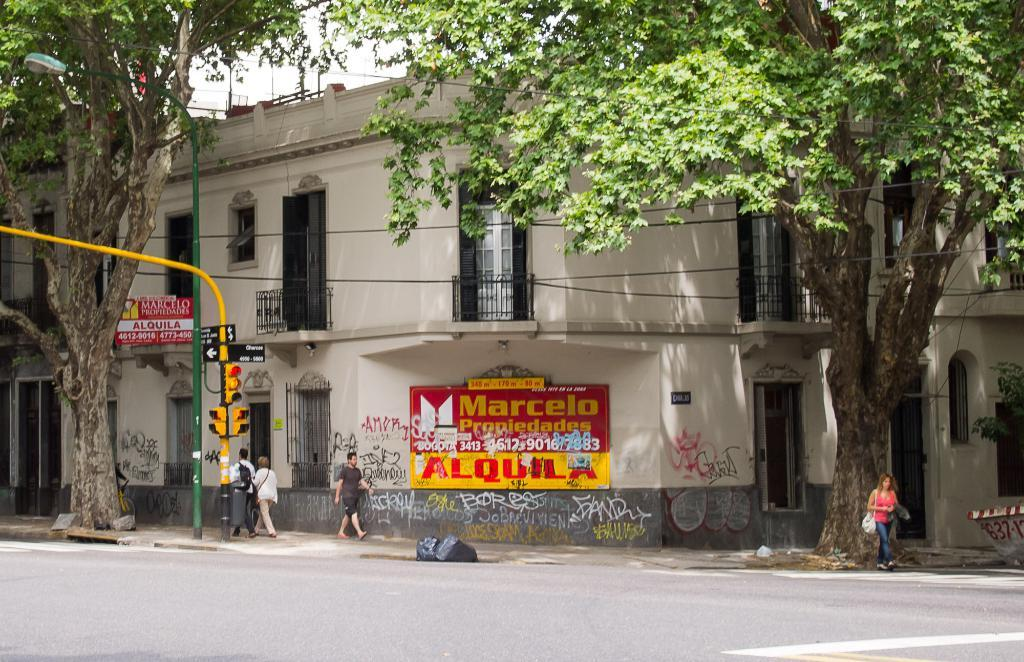How many people are in the group visible in the image? The number of people in the group cannot be determined from the provided facts. What type of vegetation is present in the image? There are trees in the image. What type of infrastructure can be seen in the image? Traffic lights and poles are visible in the image. What is on the building in the image? There are hoardings on a building in the image. What type of toy can be seen in the hands of the people in the image? There is no toy visible in the hands of the people in the image. What is the taste of the trees in the image? Trees do not have a taste, so this question cannot be answered. 